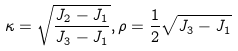<formula> <loc_0><loc_0><loc_500><loc_500>\kappa = \sqrt { \frac { J _ { 2 } - J _ { 1 } } { J _ { 3 } - J _ { 1 } } } , \rho = \frac { 1 } { 2 } \sqrt { J _ { 3 } - J _ { 1 } }</formula> 